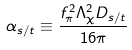Convert formula to latex. <formula><loc_0><loc_0><loc_500><loc_500>\alpha _ { s / t } \equiv \frac { f _ { \pi } ^ { 2 } \Lambda _ { \chi } ^ { 2 } D _ { s / t } } { 1 6 \pi }</formula> 